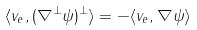Convert formula to latex. <formula><loc_0><loc_0><loc_500><loc_500>\langle v _ { e } , ( \nabla ^ { \perp } \psi ) ^ { \perp } \rangle = - \langle v _ { e } , \nabla \psi \rangle</formula> 